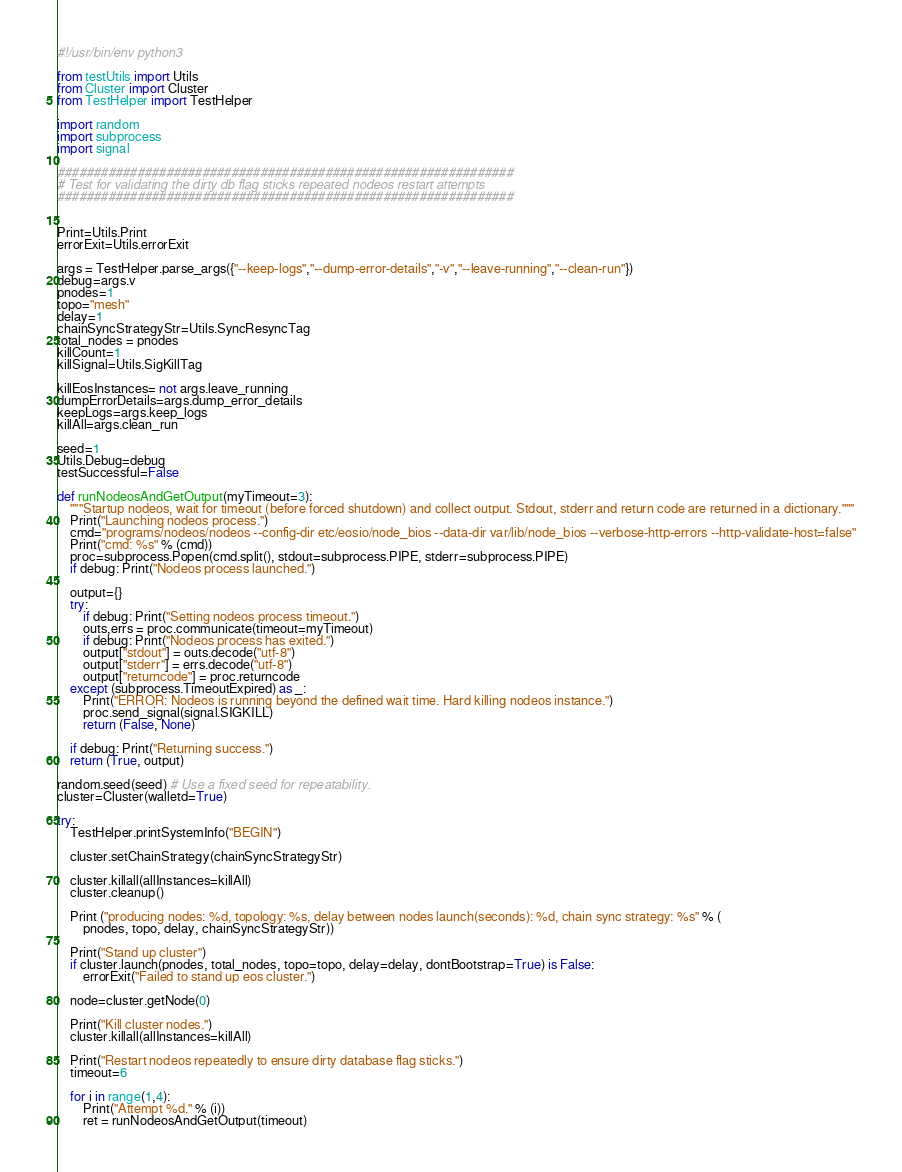<code> <loc_0><loc_0><loc_500><loc_500><_Python_>#!/usr/bin/env python3

from testUtils import Utils
from Cluster import Cluster
from TestHelper import TestHelper

import random
import subprocess
import signal

###############################################################
# Test for validating the dirty db flag sticks repeated nodeos restart attempts
###############################################################


Print=Utils.Print
errorExit=Utils.errorExit

args = TestHelper.parse_args({"--keep-logs","--dump-error-details","-v","--leave-running","--clean-run"})
debug=args.v
pnodes=1
topo="mesh"
delay=1
chainSyncStrategyStr=Utils.SyncResyncTag
total_nodes = pnodes
killCount=1
killSignal=Utils.SigKillTag

killEosInstances= not args.leave_running
dumpErrorDetails=args.dump_error_details
keepLogs=args.keep_logs
killAll=args.clean_run

seed=1
Utils.Debug=debug
testSuccessful=False

def runNodeosAndGetOutput(myTimeout=3):
    """Startup nodeos, wait for timeout (before forced shutdown) and collect output. Stdout, stderr and return code are returned in a dictionary."""
    Print("Launching nodeos process.")
    cmd="programs/nodeos/nodeos --config-dir etc/eosio/node_bios --data-dir var/lib/node_bios --verbose-http-errors --http-validate-host=false"
    Print("cmd: %s" % (cmd))
    proc=subprocess.Popen(cmd.split(), stdout=subprocess.PIPE, stderr=subprocess.PIPE)
    if debug: Print("Nodeos process launched.")

    output={}
    try:
        if debug: Print("Setting nodeos process timeout.")
        outs,errs = proc.communicate(timeout=myTimeout)
        if debug: Print("Nodeos process has exited.")
        output["stdout"] = outs.decode("utf-8")
        output["stderr"] = errs.decode("utf-8")
        output["returncode"] = proc.returncode
    except (subprocess.TimeoutExpired) as _:
        Print("ERROR: Nodeos is running beyond the defined wait time. Hard killing nodeos instance.")
        proc.send_signal(signal.SIGKILL)
        return (False, None)

    if debug: Print("Returning success.")
    return (True, output)

random.seed(seed) # Use a fixed seed for repeatability.
cluster=Cluster(walletd=True)

try:
    TestHelper.printSystemInfo("BEGIN")

    cluster.setChainStrategy(chainSyncStrategyStr)

    cluster.killall(allInstances=killAll)
    cluster.cleanup()

    Print ("producing nodes: %d, topology: %s, delay between nodes launch(seconds): %d, chain sync strategy: %s" % (
        pnodes, topo, delay, chainSyncStrategyStr))

    Print("Stand up cluster")
    if cluster.launch(pnodes, total_nodes, topo=topo, delay=delay, dontBootstrap=True) is False:
        errorExit("Failed to stand up eos cluster.")

    node=cluster.getNode(0)

    Print("Kill cluster nodes.")
    cluster.killall(allInstances=killAll)

    Print("Restart nodeos repeatedly to ensure dirty database flag sticks.")
    timeout=6

    for i in range(1,4):
        Print("Attempt %d." % (i))
        ret = runNodeosAndGetOutput(timeout)</code> 